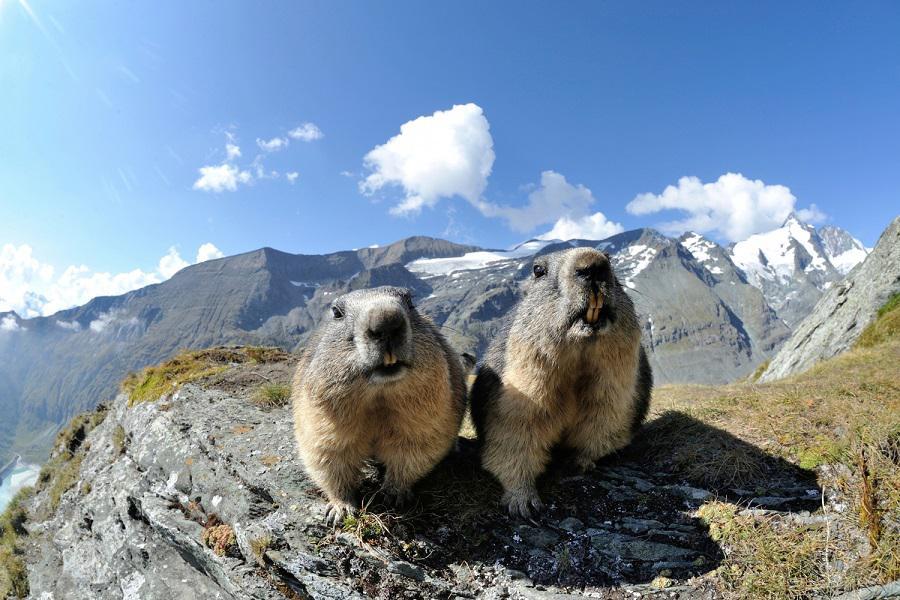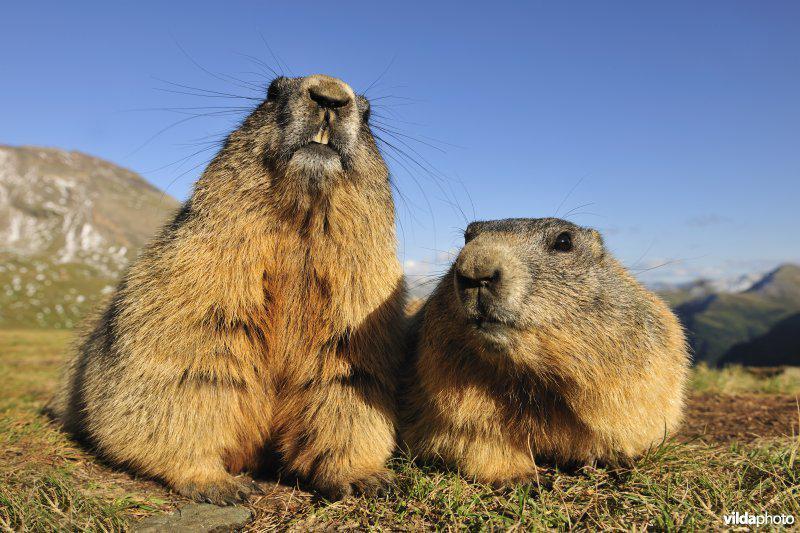The first image is the image on the left, the second image is the image on the right. Assess this claim about the two images: "Two animals are on a rocky ledge.". Correct or not? Answer yes or no. Yes. 